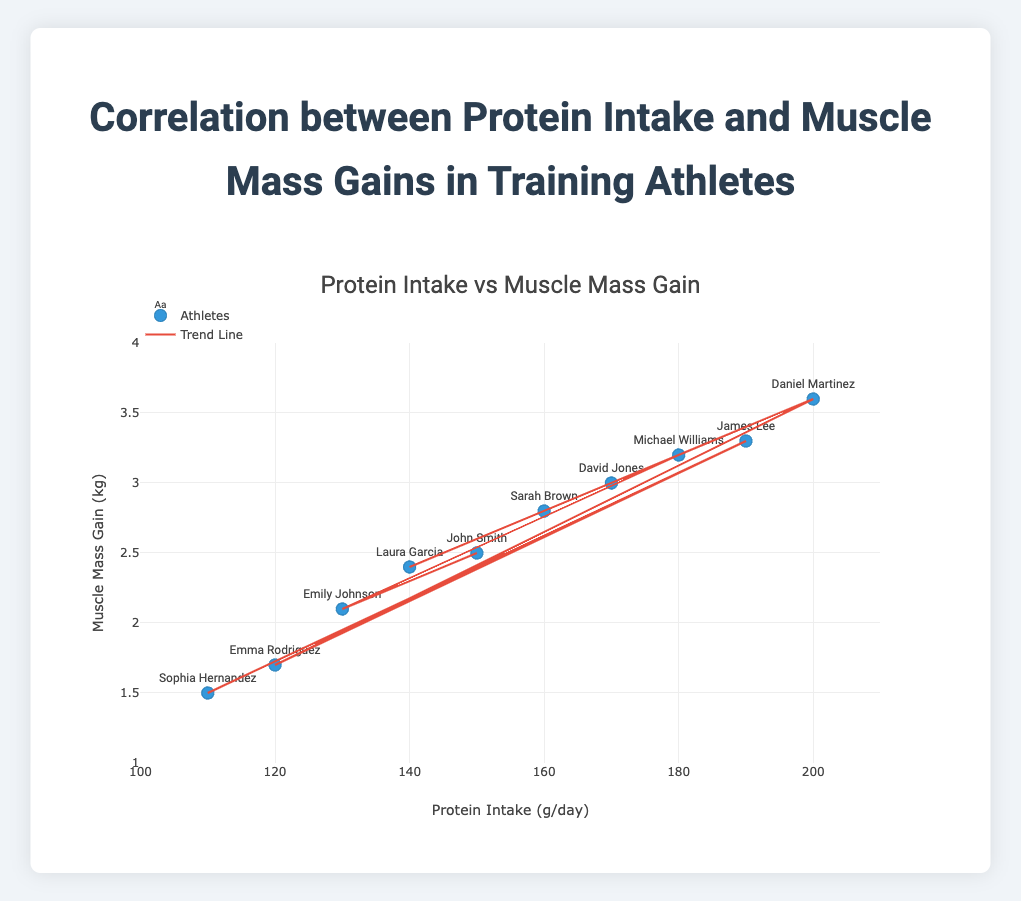What's the title of the plot? The title of the plot is usually placed at the top and can be directly read from the figure.
Answer: Correlation between Protein Intake and Muscle Mass Gains in Training Athletes How many athletes' data points are shown in the plot? To answer this question, count the number of markers (data points) on the scatter plot.
Answer: 10 What is the x-axis labeled as? The label of the x-axis is displayed along the horizontal axis of the plot.
Answer: Protein Intake (g/day) What is the range of the y-axis? The range of the y-axis can be identified by looking at the minimum and maximum values displayed along the vertical axis.
Answer: 1 to 4 kg Which athlete has the highest muscle mass gain, and what is their protein intake? Observe the data point that is highest along the y-axis and read off the corresponding values and name.
Answer: Daniel Martinez, 200 g/day Is there a trend in the data points? Examine the overall direction that the data points follow, often highlighted by the trend line.
Answer: Yes, there is a positive trend What is the average protein intake of the athletes? Sum the protein intakes of all athletes and divide by the number of athletes. Calculation: (150 + 130 + 180 + 160 + 170 + 140 + 200 + 120 + 190 + 110) / 10 = 155 g/day
Answer: 155 g/day Which athlete has the lowest muscle mass gain, and how much protein do they consume per day? Locate the data point that is lowest on the y-axis and note the corresponding x-axis value and name.
Answer: Sophia Hernandez, 110 g/day Does higher protein intake generally correlate with higher muscle mass gain in this plot? Evaluate the trend line and overall pattern of the data points to determine if higher x-values are associated with higher y-values.
Answer: Yes How does Emma Rodriguez's muscle mass gain compare to Emily Johnson's? Find the data points for both athletes and compare their y-values.
Answer: Emma Rodriguez has less muscle mass gain (1.7 kg) compared to Emily Johnson (2.1 kg) 